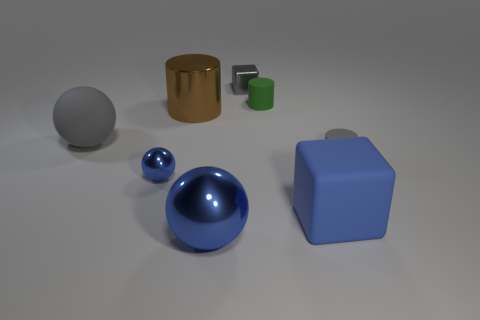Which objects in the image are the largest and the smallest? The largest object in this image appears to be the blue cube, due to its pronounced edges and solid shape. The smallest object is the tiny green cube, which sits closely to the larger shiny cylinder, distinguishable by its size and color. 